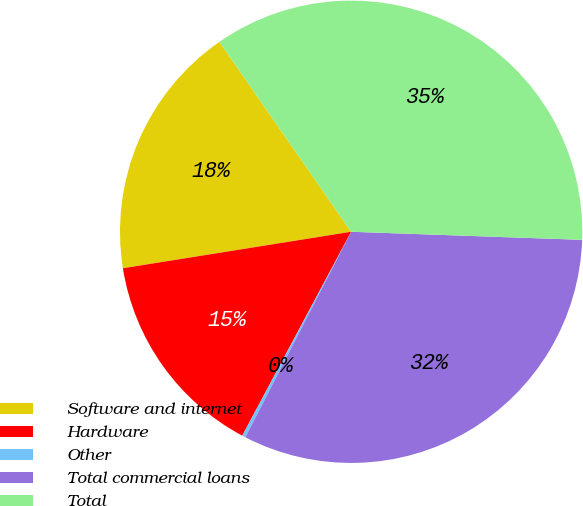Convert chart to OTSL. <chart><loc_0><loc_0><loc_500><loc_500><pie_chart><fcel>Software and internet<fcel>Hardware<fcel>Other<fcel>Total commercial loans<fcel>Total<nl><fcel>17.87%<fcel>14.67%<fcel>0.24%<fcel>32.01%<fcel>35.21%<nl></chart> 